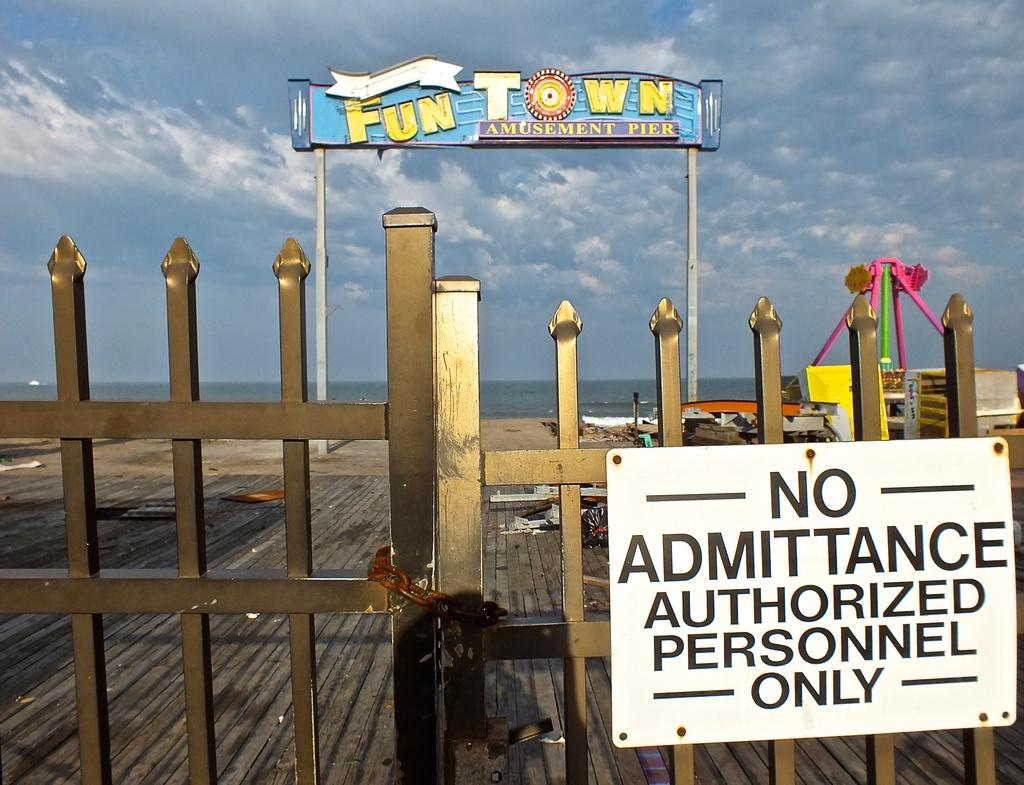<image>
Describe the image concisely. a sign in front of a gate that says 'no admittance authorized personnel only' on it 